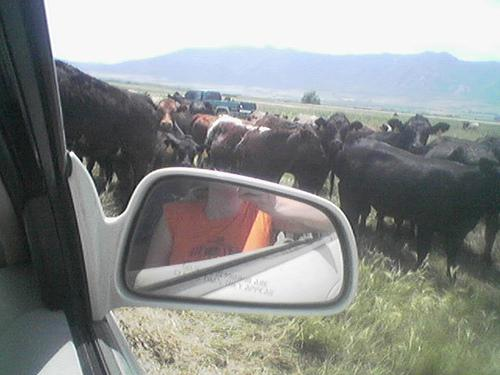Question: what else is visible?
Choices:
A. Grass.
B. Trees.
C. Flowers.
D. Animals.
Answer with the letter. Answer: A Question: how is the photo?
Choices:
A. Black and white.
B. Torn.
C. Blurred.
D. Clear.
Answer with the letter. Answer: D Question: why are there cows?
Choices:
A. Grazing.
B. Herding.
C. Branding.
D. Going to slaughter.
Answer with the letter. Answer: B 